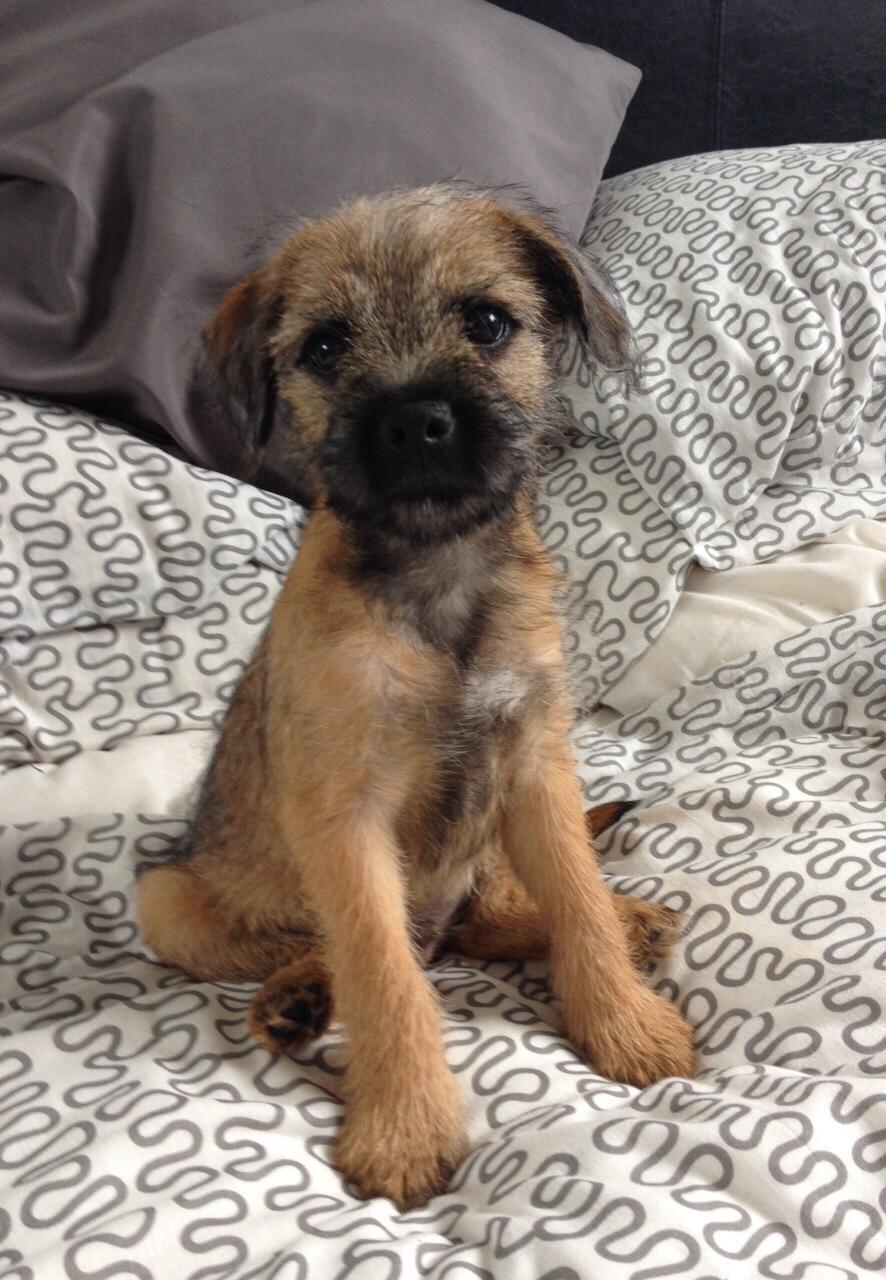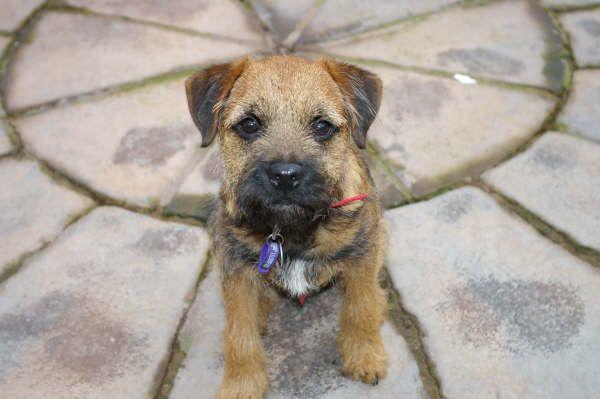The first image is the image on the left, the second image is the image on the right. For the images shown, is this caption "The dog on the left wears a red collar, and the dog on the right looks forward with a tilted head." true? Answer yes or no. No. The first image is the image on the left, the second image is the image on the right. Examine the images to the left and right. Is the description "The dog in the image on the left is wearing a red collar." accurate? Answer yes or no. No. 